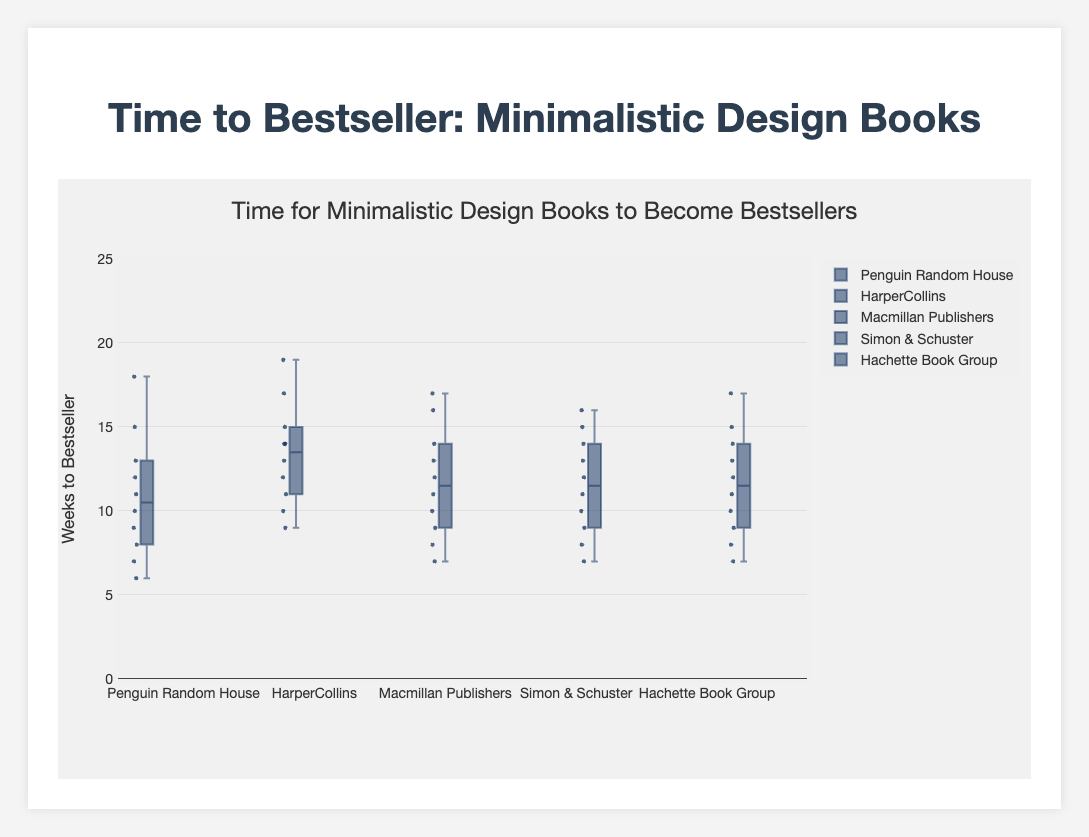What is the title of the plot? The title of the plot is located at the top and reads "Time for Minimalistic Design Books to Become Bestsellers".
Answer: Time for Minimalistic Design Books to Become Bestsellers What is the y-axis title? The y-axis title is located along the vertical axis and reads "Weeks to Bestseller".
Answer: Weeks to Bestseller Which publishing house has the shortest minimum time to become a bestseller? To determine the shortest minimum time, look for the bottom edge of the whisker in each box plot. Penguin Random House has the shortest minimum time at 6 weeks.
Answer: Penguin Random House What is the median time for HarperCollins? The median time is represented by the line inside the box. For HarperCollins, it is 14 weeks.
Answer: 14 weeks Which publishing house has the highest maximum time to become a bestseller? The highest maximum time is shown by the top edge of the whisker. HarperCollins has the highest maximum time at 19 weeks.
Answer: HarperCollins What is the interquartile range (IQR) for Macmillan Publishers? The IQR is the difference between the third quartile (Q3) and the first quartile (Q1). For Macmillan Publishers, Q3 is approximately 14 weeks and Q1 is approximately 9 weeks. Therefore, the IQR is 14 - 9 = 5 weeks.
Answer: 5 weeks Compare the median times of Simon & Schuster and Hachette Book Group. Which one is higher? The median time for Simon & Schuster is 12 weeks, and for Hachette Book Group, it's also 12 weeks.
Answer: Equal What is the range of weeks for Penguin Random House? The range is the difference between the maximum and minimum values. For Penguin Random House, the range is 18 - 6 = 12 weeks.
Answer: 12 weeks How many publishing houses have median times below 13 weeks? Check the median lines in each box plot: Penguin Random House (11 weeks), Macmillan Publishers (10 weeks), Simon & Schuster (12 weeks), and Hachette Book Group (12 weeks). So, 4 publishing houses have medians below 13 weeks.
Answer: 4 